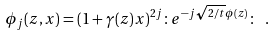<formula> <loc_0><loc_0><loc_500><loc_500>\phi _ { j } ( z , x ) = ( 1 + \gamma ( z ) x ) ^ { 2 j } \colon e ^ { - j \sqrt { 2 / t } \phi ( z ) } \colon \ .</formula> 